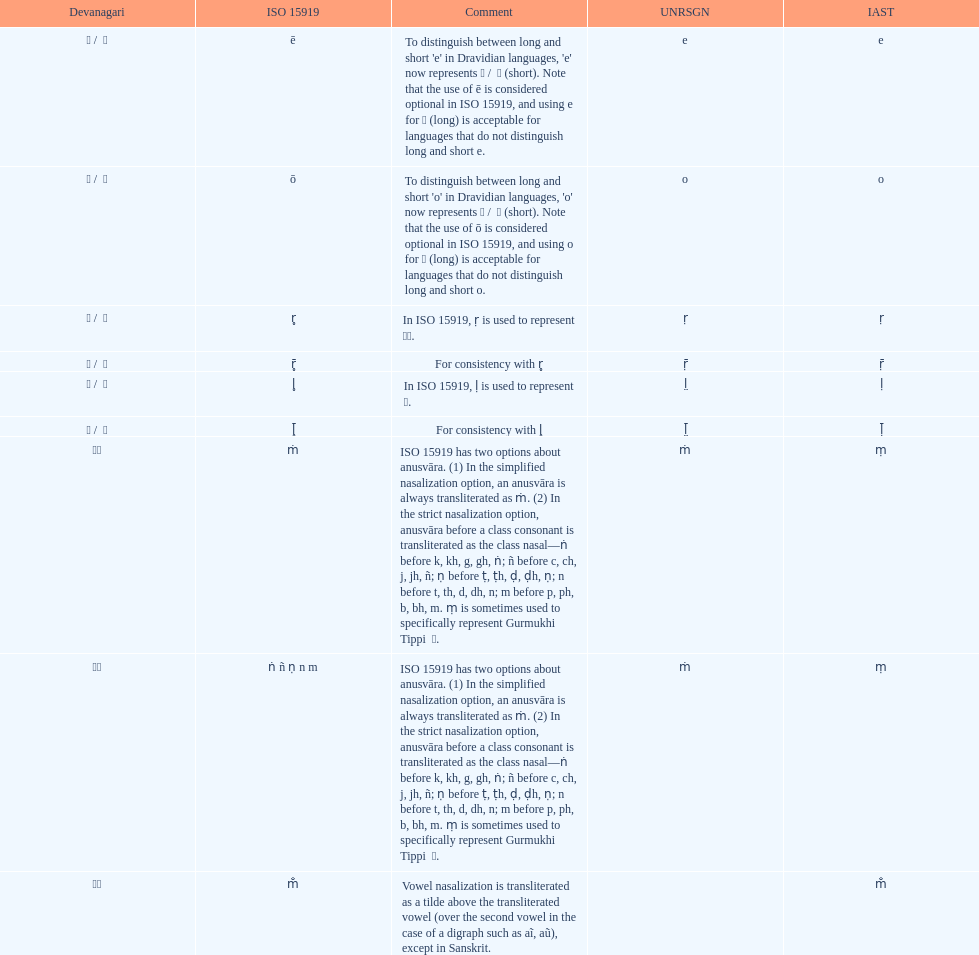This table shows the difference between how many transliterations? 3. 